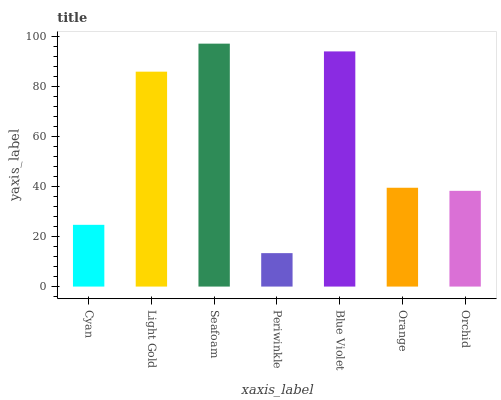Is Light Gold the minimum?
Answer yes or no. No. Is Light Gold the maximum?
Answer yes or no. No. Is Light Gold greater than Cyan?
Answer yes or no. Yes. Is Cyan less than Light Gold?
Answer yes or no. Yes. Is Cyan greater than Light Gold?
Answer yes or no. No. Is Light Gold less than Cyan?
Answer yes or no. No. Is Orange the high median?
Answer yes or no. Yes. Is Orange the low median?
Answer yes or no. Yes. Is Light Gold the high median?
Answer yes or no. No. Is Cyan the low median?
Answer yes or no. No. 